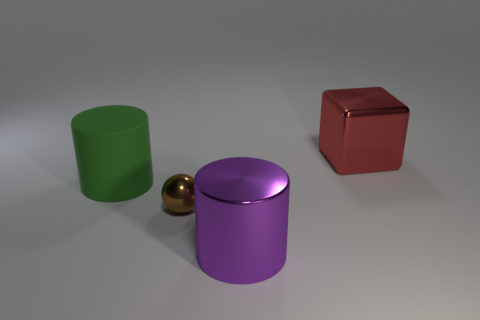What number of other things are there of the same size as the block?
Make the answer very short. 2. What is the shape of the metallic object behind the cylinder that is on the left side of the big metallic object that is left of the block?
Ensure brevity in your answer.  Cube. What number of brown objects are big matte spheres or spheres?
Provide a short and direct response. 1. There is a thing that is on the left side of the brown metallic object; what number of red metallic objects are behind it?
Your answer should be compact. 1. Is there any other thing that has the same color as the rubber object?
Your response must be concise. No. What is the shape of the large red thing that is the same material as the small brown thing?
Ensure brevity in your answer.  Cube. Does the rubber object have the same color as the big metallic cube?
Your answer should be compact. No. Are the cylinder in front of the brown metallic ball and the big cylinder that is behind the tiny brown ball made of the same material?
Make the answer very short. No. What number of things are either large cubes or big cylinders that are to the right of the green rubber thing?
Give a very brief answer. 2. Are there any other things that have the same material as the red block?
Offer a very short reply. Yes. 